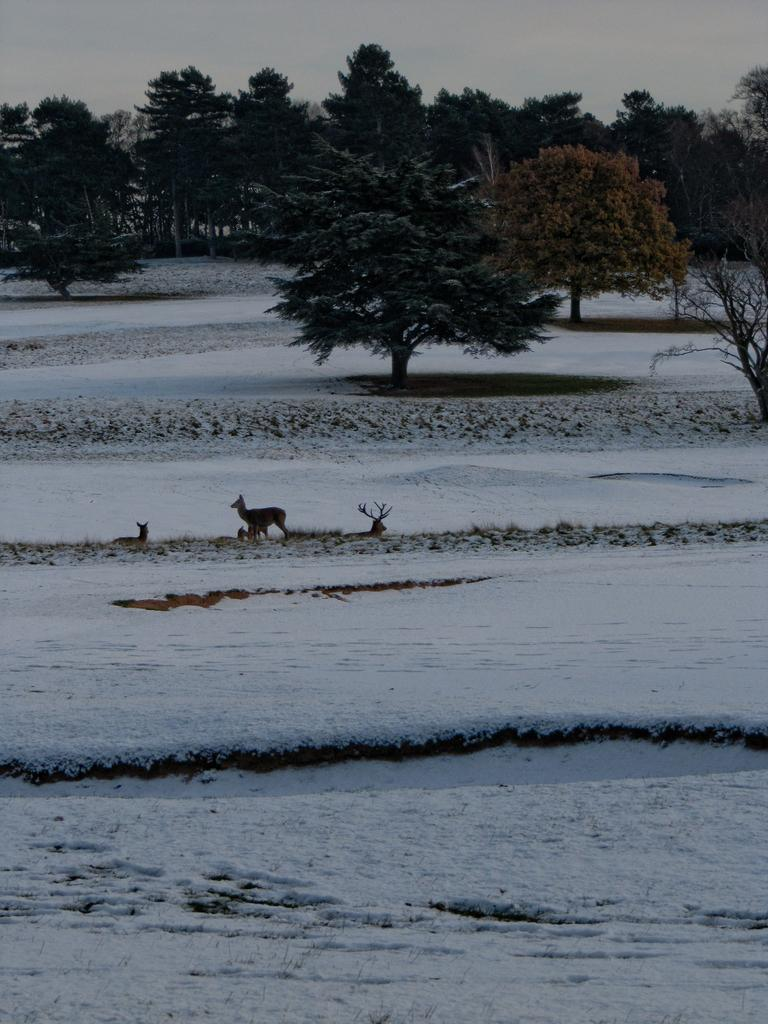What type of animals can be seen in the image? There are deers in the image. What is the weather like in the image? There is snow in the image, which suggests a cold or wintery environment. What type of vegetation is present in the image? There are trees in the image. What can be seen in the background of the image? The sky is visible in the background of the image. What type of stew is being prepared in the image? There is no stew present in the image; it features deers in a snowy environment with trees and a visible sky. 